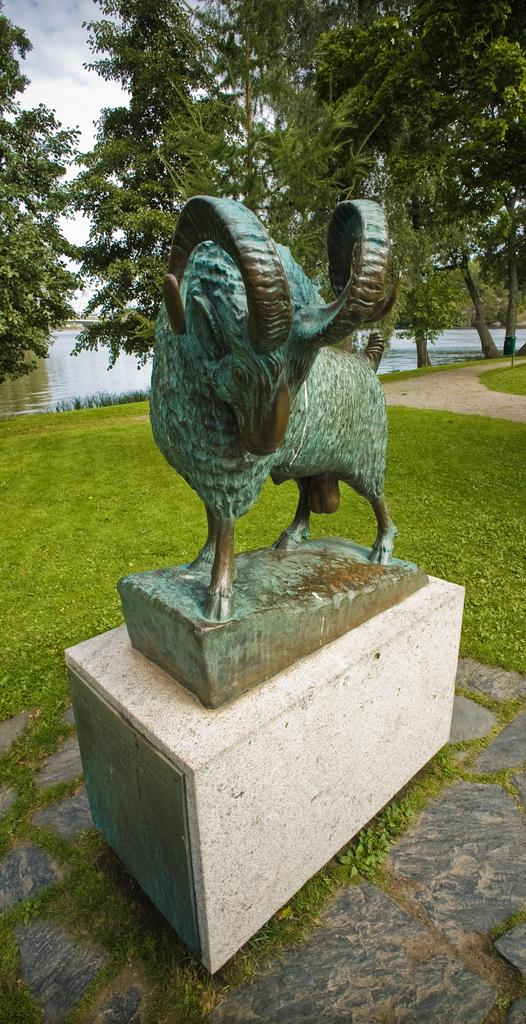What is the main subject in the image? There is a statue in the image. What type of natural environment is visible in the image? There is grass, water, and trees in the image. What can be seen in the background of the image? The sky with clouds is visible in the background of the image. What type of tax is being discussed in the image? There is no discussion of tax in the image; it features a statue in a natural environment with a sky background. 